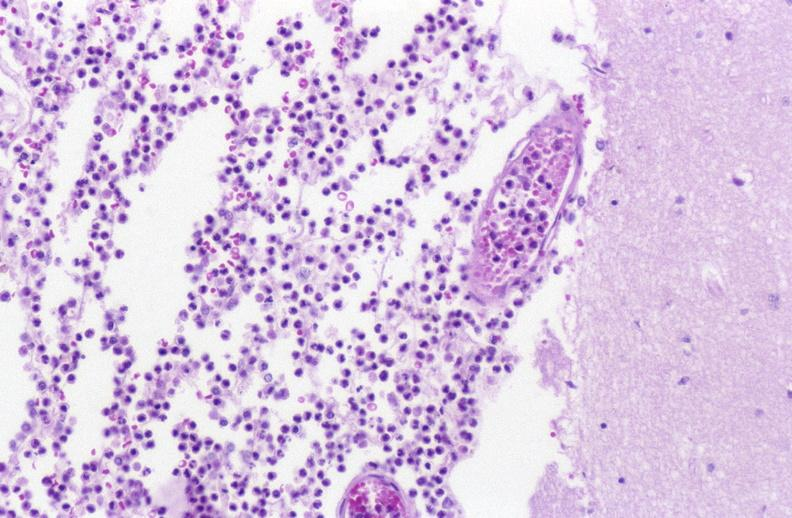s nervous present?
Answer the question using a single word or phrase. Yes 